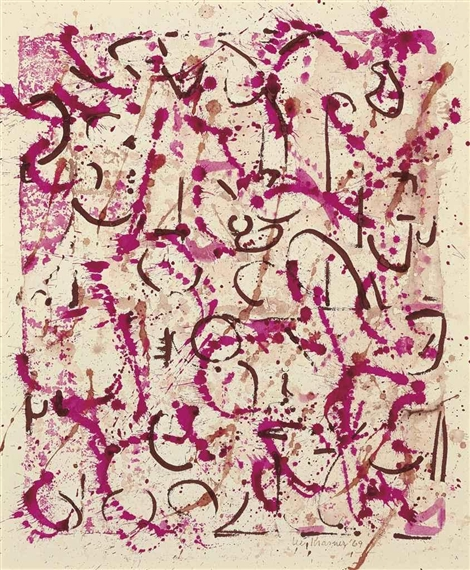What emotions do you think this artwork conveys? The artwork appears to evoke a range of emotions, primarily due to its dynamic composition and vibrant color palette. The bold pink and black lines in the painting create a sense of energy, passion, and perhaps even chaos. The spontaneity of the splatters and streaks can convey a feeling of liberation and unrestrained creativity. The viewer might feel invigorated, curious, and possibly introspective, as the abstract forms can trigger personal reflections and interpretations. 